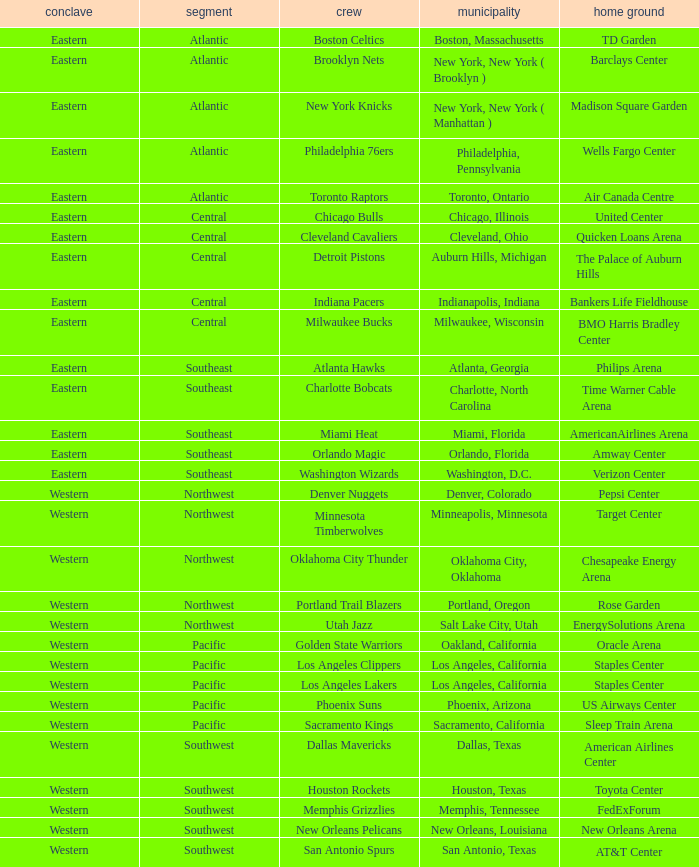Parse the table in full. {'header': ['conclave', 'segment', 'crew', 'municipality', 'home ground'], 'rows': [['Eastern', 'Atlantic', 'Boston Celtics', 'Boston, Massachusetts', 'TD Garden'], ['Eastern', 'Atlantic', 'Brooklyn Nets', 'New York, New York ( Brooklyn )', 'Barclays Center'], ['Eastern', 'Atlantic', 'New York Knicks', 'New York, New York ( Manhattan )', 'Madison Square Garden'], ['Eastern', 'Atlantic', 'Philadelphia 76ers', 'Philadelphia, Pennsylvania', 'Wells Fargo Center'], ['Eastern', 'Atlantic', 'Toronto Raptors', 'Toronto, Ontario', 'Air Canada Centre'], ['Eastern', 'Central', 'Chicago Bulls', 'Chicago, Illinois', 'United Center'], ['Eastern', 'Central', 'Cleveland Cavaliers', 'Cleveland, Ohio', 'Quicken Loans Arena'], ['Eastern', 'Central', 'Detroit Pistons', 'Auburn Hills, Michigan', 'The Palace of Auburn Hills'], ['Eastern', 'Central', 'Indiana Pacers', 'Indianapolis, Indiana', 'Bankers Life Fieldhouse'], ['Eastern', 'Central', 'Milwaukee Bucks', 'Milwaukee, Wisconsin', 'BMO Harris Bradley Center'], ['Eastern', 'Southeast', 'Atlanta Hawks', 'Atlanta, Georgia', 'Philips Arena'], ['Eastern', 'Southeast', 'Charlotte Bobcats', 'Charlotte, North Carolina', 'Time Warner Cable Arena'], ['Eastern', 'Southeast', 'Miami Heat', 'Miami, Florida', 'AmericanAirlines Arena'], ['Eastern', 'Southeast', 'Orlando Magic', 'Orlando, Florida', 'Amway Center'], ['Eastern', 'Southeast', 'Washington Wizards', 'Washington, D.C.', 'Verizon Center'], ['Western', 'Northwest', 'Denver Nuggets', 'Denver, Colorado', 'Pepsi Center'], ['Western', 'Northwest', 'Minnesota Timberwolves', 'Minneapolis, Minnesota', 'Target Center'], ['Western', 'Northwest', 'Oklahoma City Thunder', 'Oklahoma City, Oklahoma', 'Chesapeake Energy Arena'], ['Western', 'Northwest', 'Portland Trail Blazers', 'Portland, Oregon', 'Rose Garden'], ['Western', 'Northwest', 'Utah Jazz', 'Salt Lake City, Utah', 'EnergySolutions Arena'], ['Western', 'Pacific', 'Golden State Warriors', 'Oakland, California', 'Oracle Arena'], ['Western', 'Pacific', 'Los Angeles Clippers', 'Los Angeles, California', 'Staples Center'], ['Western', 'Pacific', 'Los Angeles Lakers', 'Los Angeles, California', 'Staples Center'], ['Western', 'Pacific', 'Phoenix Suns', 'Phoenix, Arizona', 'US Airways Center'], ['Western', 'Pacific', 'Sacramento Kings', 'Sacramento, California', 'Sleep Train Arena'], ['Western', 'Southwest', 'Dallas Mavericks', 'Dallas, Texas', 'American Airlines Center'], ['Western', 'Southwest', 'Houston Rockets', 'Houston, Texas', 'Toyota Center'], ['Western', 'Southwest', 'Memphis Grizzlies', 'Memphis, Tennessee', 'FedExForum'], ['Western', 'Southwest', 'New Orleans Pelicans', 'New Orleans, Louisiana', 'New Orleans Arena'], ['Western', 'Southwest', 'San Antonio Spurs', 'San Antonio, Texas', 'AT&T Center']]} Which conference is in Portland, Oregon? Western. 